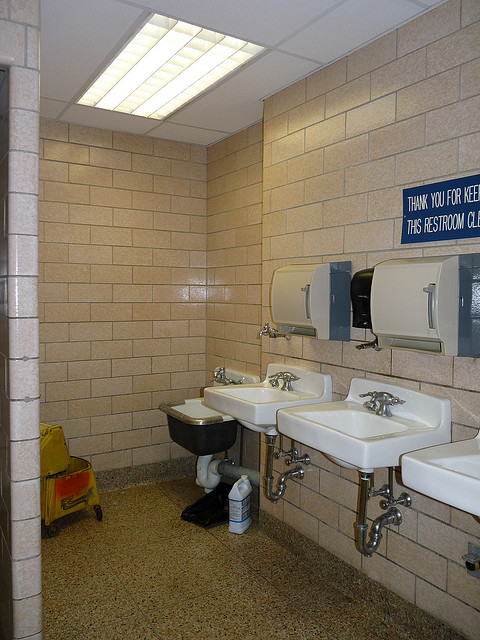Read and extract the text from this image. THANK THIS RESTROOM YOU FOR KEE 